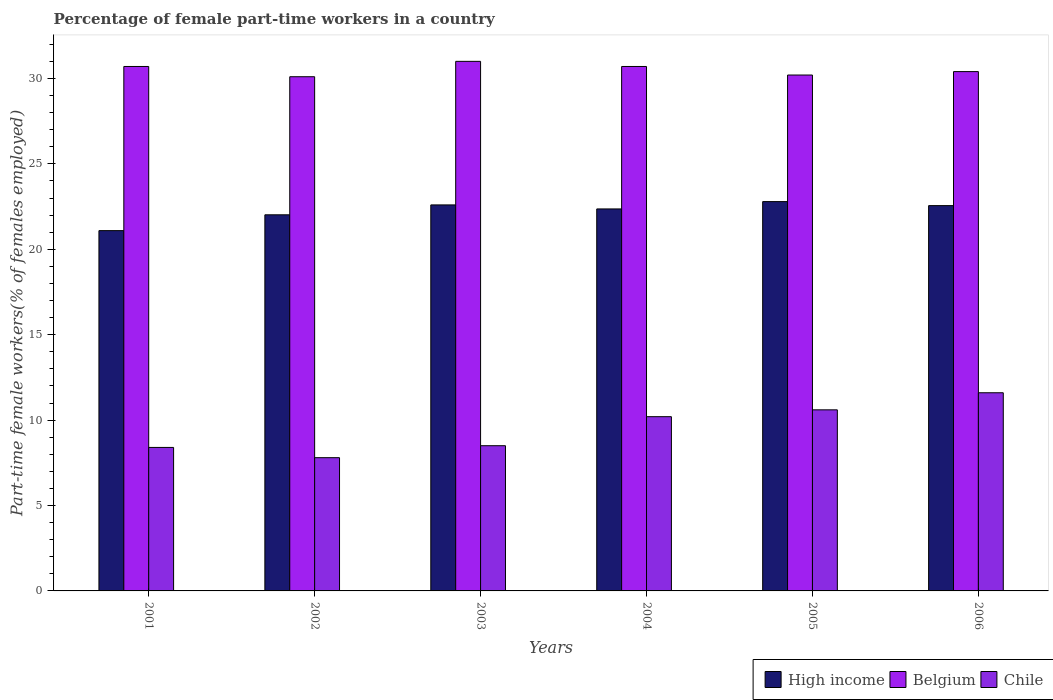How many groups of bars are there?
Keep it short and to the point. 6. Are the number of bars on each tick of the X-axis equal?
Ensure brevity in your answer.  Yes. What is the label of the 3rd group of bars from the left?
Provide a succinct answer. 2003. What is the percentage of female part-time workers in High income in 2001?
Your response must be concise. 21.09. Across all years, what is the minimum percentage of female part-time workers in High income?
Provide a short and direct response. 21.09. In which year was the percentage of female part-time workers in Chile minimum?
Provide a short and direct response. 2002. What is the total percentage of female part-time workers in Chile in the graph?
Your answer should be compact. 57.1. What is the difference between the percentage of female part-time workers in Belgium in 2003 and that in 2006?
Your answer should be compact. 0.6. What is the difference between the percentage of female part-time workers in High income in 2001 and the percentage of female part-time workers in Belgium in 2006?
Your response must be concise. -9.31. What is the average percentage of female part-time workers in High income per year?
Make the answer very short. 22.24. In the year 2001, what is the difference between the percentage of female part-time workers in Chile and percentage of female part-time workers in High income?
Provide a short and direct response. -12.69. In how many years, is the percentage of female part-time workers in Chile greater than 14 %?
Provide a succinct answer. 0. What is the ratio of the percentage of female part-time workers in Belgium in 2002 to that in 2006?
Keep it short and to the point. 0.99. What is the difference between the highest and the lowest percentage of female part-time workers in High income?
Ensure brevity in your answer.  1.7. In how many years, is the percentage of female part-time workers in Belgium greater than the average percentage of female part-time workers in Belgium taken over all years?
Provide a succinct answer. 3. Is the sum of the percentage of female part-time workers in Belgium in 2001 and 2003 greater than the maximum percentage of female part-time workers in Chile across all years?
Provide a succinct answer. Yes. What does the 1st bar from the left in 2005 represents?
Your response must be concise. High income. Is it the case that in every year, the sum of the percentage of female part-time workers in Belgium and percentage of female part-time workers in High income is greater than the percentage of female part-time workers in Chile?
Your answer should be compact. Yes. How many years are there in the graph?
Provide a short and direct response. 6. Are the values on the major ticks of Y-axis written in scientific E-notation?
Your answer should be very brief. No. Does the graph contain any zero values?
Provide a short and direct response. No. What is the title of the graph?
Your response must be concise. Percentage of female part-time workers in a country. Does "Slovak Republic" appear as one of the legend labels in the graph?
Offer a very short reply. No. What is the label or title of the X-axis?
Your response must be concise. Years. What is the label or title of the Y-axis?
Offer a terse response. Part-time female workers(% of females employed). What is the Part-time female workers(% of females employed) in High income in 2001?
Ensure brevity in your answer.  21.09. What is the Part-time female workers(% of females employed) in Belgium in 2001?
Provide a succinct answer. 30.7. What is the Part-time female workers(% of females employed) in Chile in 2001?
Ensure brevity in your answer.  8.4. What is the Part-time female workers(% of females employed) of High income in 2002?
Offer a very short reply. 22.02. What is the Part-time female workers(% of females employed) of Belgium in 2002?
Offer a very short reply. 30.1. What is the Part-time female workers(% of females employed) of Chile in 2002?
Your answer should be compact. 7.8. What is the Part-time female workers(% of females employed) in High income in 2003?
Your answer should be compact. 22.6. What is the Part-time female workers(% of females employed) in Belgium in 2003?
Provide a short and direct response. 31. What is the Part-time female workers(% of females employed) of Chile in 2003?
Offer a terse response. 8.5. What is the Part-time female workers(% of females employed) of High income in 2004?
Make the answer very short. 22.36. What is the Part-time female workers(% of females employed) of Belgium in 2004?
Make the answer very short. 30.7. What is the Part-time female workers(% of females employed) of Chile in 2004?
Your response must be concise. 10.2. What is the Part-time female workers(% of females employed) in High income in 2005?
Your response must be concise. 22.79. What is the Part-time female workers(% of females employed) of Belgium in 2005?
Your answer should be very brief. 30.2. What is the Part-time female workers(% of females employed) in Chile in 2005?
Offer a terse response. 10.6. What is the Part-time female workers(% of females employed) in High income in 2006?
Your response must be concise. 22.55. What is the Part-time female workers(% of females employed) of Belgium in 2006?
Make the answer very short. 30.4. What is the Part-time female workers(% of females employed) in Chile in 2006?
Your answer should be very brief. 11.6. Across all years, what is the maximum Part-time female workers(% of females employed) in High income?
Provide a succinct answer. 22.79. Across all years, what is the maximum Part-time female workers(% of females employed) of Belgium?
Offer a terse response. 31. Across all years, what is the maximum Part-time female workers(% of females employed) of Chile?
Offer a terse response. 11.6. Across all years, what is the minimum Part-time female workers(% of females employed) in High income?
Keep it short and to the point. 21.09. Across all years, what is the minimum Part-time female workers(% of females employed) of Belgium?
Give a very brief answer. 30.1. Across all years, what is the minimum Part-time female workers(% of females employed) of Chile?
Your answer should be very brief. 7.8. What is the total Part-time female workers(% of females employed) in High income in the graph?
Provide a succinct answer. 133.41. What is the total Part-time female workers(% of females employed) of Belgium in the graph?
Provide a short and direct response. 183.1. What is the total Part-time female workers(% of females employed) in Chile in the graph?
Your response must be concise. 57.1. What is the difference between the Part-time female workers(% of females employed) of High income in 2001 and that in 2002?
Ensure brevity in your answer.  -0.93. What is the difference between the Part-time female workers(% of females employed) in Chile in 2001 and that in 2002?
Make the answer very short. 0.6. What is the difference between the Part-time female workers(% of females employed) of High income in 2001 and that in 2003?
Offer a terse response. -1.51. What is the difference between the Part-time female workers(% of females employed) in Belgium in 2001 and that in 2003?
Offer a very short reply. -0.3. What is the difference between the Part-time female workers(% of females employed) of High income in 2001 and that in 2004?
Offer a terse response. -1.27. What is the difference between the Part-time female workers(% of females employed) in Belgium in 2001 and that in 2004?
Your response must be concise. 0. What is the difference between the Part-time female workers(% of females employed) of High income in 2001 and that in 2005?
Keep it short and to the point. -1.7. What is the difference between the Part-time female workers(% of females employed) of Chile in 2001 and that in 2005?
Keep it short and to the point. -2.2. What is the difference between the Part-time female workers(% of females employed) in High income in 2001 and that in 2006?
Your answer should be compact. -1.46. What is the difference between the Part-time female workers(% of females employed) in High income in 2002 and that in 2003?
Your answer should be compact. -0.58. What is the difference between the Part-time female workers(% of females employed) in Chile in 2002 and that in 2003?
Give a very brief answer. -0.7. What is the difference between the Part-time female workers(% of females employed) in High income in 2002 and that in 2004?
Your response must be concise. -0.34. What is the difference between the Part-time female workers(% of females employed) of High income in 2002 and that in 2005?
Offer a very short reply. -0.77. What is the difference between the Part-time female workers(% of females employed) in High income in 2002 and that in 2006?
Give a very brief answer. -0.54. What is the difference between the Part-time female workers(% of females employed) in Belgium in 2002 and that in 2006?
Keep it short and to the point. -0.3. What is the difference between the Part-time female workers(% of females employed) in Chile in 2002 and that in 2006?
Provide a succinct answer. -3.8. What is the difference between the Part-time female workers(% of females employed) of High income in 2003 and that in 2004?
Make the answer very short. 0.24. What is the difference between the Part-time female workers(% of females employed) of Chile in 2003 and that in 2004?
Your response must be concise. -1.7. What is the difference between the Part-time female workers(% of females employed) in High income in 2003 and that in 2005?
Keep it short and to the point. -0.19. What is the difference between the Part-time female workers(% of females employed) in Chile in 2003 and that in 2005?
Keep it short and to the point. -2.1. What is the difference between the Part-time female workers(% of females employed) in High income in 2003 and that in 2006?
Ensure brevity in your answer.  0.04. What is the difference between the Part-time female workers(% of females employed) of Chile in 2003 and that in 2006?
Provide a short and direct response. -3.1. What is the difference between the Part-time female workers(% of females employed) of High income in 2004 and that in 2005?
Provide a short and direct response. -0.43. What is the difference between the Part-time female workers(% of females employed) in High income in 2004 and that in 2006?
Offer a terse response. -0.19. What is the difference between the Part-time female workers(% of females employed) in Belgium in 2004 and that in 2006?
Keep it short and to the point. 0.3. What is the difference between the Part-time female workers(% of females employed) of Chile in 2004 and that in 2006?
Your answer should be compact. -1.4. What is the difference between the Part-time female workers(% of females employed) of High income in 2005 and that in 2006?
Your response must be concise. 0.24. What is the difference between the Part-time female workers(% of females employed) of Belgium in 2005 and that in 2006?
Offer a very short reply. -0.2. What is the difference between the Part-time female workers(% of females employed) of Chile in 2005 and that in 2006?
Provide a succinct answer. -1. What is the difference between the Part-time female workers(% of females employed) of High income in 2001 and the Part-time female workers(% of females employed) of Belgium in 2002?
Your answer should be compact. -9.01. What is the difference between the Part-time female workers(% of females employed) of High income in 2001 and the Part-time female workers(% of females employed) of Chile in 2002?
Make the answer very short. 13.29. What is the difference between the Part-time female workers(% of females employed) in Belgium in 2001 and the Part-time female workers(% of females employed) in Chile in 2002?
Offer a terse response. 22.9. What is the difference between the Part-time female workers(% of females employed) of High income in 2001 and the Part-time female workers(% of females employed) of Belgium in 2003?
Keep it short and to the point. -9.91. What is the difference between the Part-time female workers(% of females employed) of High income in 2001 and the Part-time female workers(% of females employed) of Chile in 2003?
Offer a terse response. 12.59. What is the difference between the Part-time female workers(% of females employed) in Belgium in 2001 and the Part-time female workers(% of females employed) in Chile in 2003?
Give a very brief answer. 22.2. What is the difference between the Part-time female workers(% of females employed) in High income in 2001 and the Part-time female workers(% of females employed) in Belgium in 2004?
Ensure brevity in your answer.  -9.61. What is the difference between the Part-time female workers(% of females employed) in High income in 2001 and the Part-time female workers(% of females employed) in Chile in 2004?
Give a very brief answer. 10.89. What is the difference between the Part-time female workers(% of females employed) in Belgium in 2001 and the Part-time female workers(% of females employed) in Chile in 2004?
Offer a very short reply. 20.5. What is the difference between the Part-time female workers(% of females employed) in High income in 2001 and the Part-time female workers(% of females employed) in Belgium in 2005?
Provide a succinct answer. -9.11. What is the difference between the Part-time female workers(% of females employed) in High income in 2001 and the Part-time female workers(% of females employed) in Chile in 2005?
Your response must be concise. 10.49. What is the difference between the Part-time female workers(% of females employed) of Belgium in 2001 and the Part-time female workers(% of females employed) of Chile in 2005?
Keep it short and to the point. 20.1. What is the difference between the Part-time female workers(% of females employed) of High income in 2001 and the Part-time female workers(% of females employed) of Belgium in 2006?
Offer a very short reply. -9.31. What is the difference between the Part-time female workers(% of females employed) of High income in 2001 and the Part-time female workers(% of females employed) of Chile in 2006?
Ensure brevity in your answer.  9.49. What is the difference between the Part-time female workers(% of females employed) in Belgium in 2001 and the Part-time female workers(% of females employed) in Chile in 2006?
Offer a very short reply. 19.1. What is the difference between the Part-time female workers(% of females employed) of High income in 2002 and the Part-time female workers(% of females employed) of Belgium in 2003?
Keep it short and to the point. -8.98. What is the difference between the Part-time female workers(% of females employed) in High income in 2002 and the Part-time female workers(% of females employed) in Chile in 2003?
Keep it short and to the point. 13.52. What is the difference between the Part-time female workers(% of females employed) in Belgium in 2002 and the Part-time female workers(% of females employed) in Chile in 2003?
Ensure brevity in your answer.  21.6. What is the difference between the Part-time female workers(% of females employed) in High income in 2002 and the Part-time female workers(% of females employed) in Belgium in 2004?
Provide a short and direct response. -8.68. What is the difference between the Part-time female workers(% of females employed) of High income in 2002 and the Part-time female workers(% of females employed) of Chile in 2004?
Your answer should be very brief. 11.82. What is the difference between the Part-time female workers(% of females employed) in Belgium in 2002 and the Part-time female workers(% of females employed) in Chile in 2004?
Your answer should be compact. 19.9. What is the difference between the Part-time female workers(% of females employed) in High income in 2002 and the Part-time female workers(% of females employed) in Belgium in 2005?
Your answer should be compact. -8.18. What is the difference between the Part-time female workers(% of females employed) in High income in 2002 and the Part-time female workers(% of females employed) in Chile in 2005?
Ensure brevity in your answer.  11.42. What is the difference between the Part-time female workers(% of females employed) in Belgium in 2002 and the Part-time female workers(% of females employed) in Chile in 2005?
Give a very brief answer. 19.5. What is the difference between the Part-time female workers(% of females employed) in High income in 2002 and the Part-time female workers(% of females employed) in Belgium in 2006?
Offer a very short reply. -8.38. What is the difference between the Part-time female workers(% of females employed) in High income in 2002 and the Part-time female workers(% of females employed) in Chile in 2006?
Give a very brief answer. 10.42. What is the difference between the Part-time female workers(% of females employed) of Belgium in 2002 and the Part-time female workers(% of females employed) of Chile in 2006?
Your answer should be compact. 18.5. What is the difference between the Part-time female workers(% of females employed) of High income in 2003 and the Part-time female workers(% of females employed) of Belgium in 2004?
Ensure brevity in your answer.  -8.1. What is the difference between the Part-time female workers(% of females employed) in High income in 2003 and the Part-time female workers(% of females employed) in Chile in 2004?
Offer a very short reply. 12.4. What is the difference between the Part-time female workers(% of females employed) of Belgium in 2003 and the Part-time female workers(% of females employed) of Chile in 2004?
Provide a succinct answer. 20.8. What is the difference between the Part-time female workers(% of females employed) in High income in 2003 and the Part-time female workers(% of females employed) in Belgium in 2005?
Provide a succinct answer. -7.6. What is the difference between the Part-time female workers(% of females employed) of High income in 2003 and the Part-time female workers(% of females employed) of Chile in 2005?
Make the answer very short. 12. What is the difference between the Part-time female workers(% of females employed) of Belgium in 2003 and the Part-time female workers(% of females employed) of Chile in 2005?
Give a very brief answer. 20.4. What is the difference between the Part-time female workers(% of females employed) of High income in 2003 and the Part-time female workers(% of females employed) of Belgium in 2006?
Your answer should be very brief. -7.8. What is the difference between the Part-time female workers(% of females employed) of High income in 2003 and the Part-time female workers(% of females employed) of Chile in 2006?
Offer a very short reply. 11. What is the difference between the Part-time female workers(% of females employed) of High income in 2004 and the Part-time female workers(% of females employed) of Belgium in 2005?
Give a very brief answer. -7.84. What is the difference between the Part-time female workers(% of females employed) of High income in 2004 and the Part-time female workers(% of females employed) of Chile in 2005?
Provide a short and direct response. 11.76. What is the difference between the Part-time female workers(% of females employed) of Belgium in 2004 and the Part-time female workers(% of females employed) of Chile in 2005?
Give a very brief answer. 20.1. What is the difference between the Part-time female workers(% of females employed) of High income in 2004 and the Part-time female workers(% of females employed) of Belgium in 2006?
Give a very brief answer. -8.04. What is the difference between the Part-time female workers(% of females employed) in High income in 2004 and the Part-time female workers(% of females employed) in Chile in 2006?
Offer a very short reply. 10.76. What is the difference between the Part-time female workers(% of females employed) of High income in 2005 and the Part-time female workers(% of females employed) of Belgium in 2006?
Give a very brief answer. -7.61. What is the difference between the Part-time female workers(% of females employed) in High income in 2005 and the Part-time female workers(% of females employed) in Chile in 2006?
Your answer should be very brief. 11.19. What is the average Part-time female workers(% of females employed) of High income per year?
Your answer should be very brief. 22.24. What is the average Part-time female workers(% of females employed) in Belgium per year?
Your answer should be compact. 30.52. What is the average Part-time female workers(% of females employed) in Chile per year?
Offer a terse response. 9.52. In the year 2001, what is the difference between the Part-time female workers(% of females employed) of High income and Part-time female workers(% of females employed) of Belgium?
Provide a succinct answer. -9.61. In the year 2001, what is the difference between the Part-time female workers(% of females employed) in High income and Part-time female workers(% of females employed) in Chile?
Your answer should be very brief. 12.69. In the year 2001, what is the difference between the Part-time female workers(% of females employed) of Belgium and Part-time female workers(% of females employed) of Chile?
Provide a short and direct response. 22.3. In the year 2002, what is the difference between the Part-time female workers(% of females employed) of High income and Part-time female workers(% of females employed) of Belgium?
Your response must be concise. -8.08. In the year 2002, what is the difference between the Part-time female workers(% of females employed) of High income and Part-time female workers(% of females employed) of Chile?
Provide a succinct answer. 14.22. In the year 2002, what is the difference between the Part-time female workers(% of females employed) in Belgium and Part-time female workers(% of females employed) in Chile?
Ensure brevity in your answer.  22.3. In the year 2003, what is the difference between the Part-time female workers(% of females employed) of High income and Part-time female workers(% of females employed) of Belgium?
Your answer should be very brief. -8.4. In the year 2003, what is the difference between the Part-time female workers(% of females employed) of High income and Part-time female workers(% of females employed) of Chile?
Your answer should be very brief. 14.1. In the year 2003, what is the difference between the Part-time female workers(% of females employed) in Belgium and Part-time female workers(% of females employed) in Chile?
Make the answer very short. 22.5. In the year 2004, what is the difference between the Part-time female workers(% of females employed) in High income and Part-time female workers(% of females employed) in Belgium?
Provide a short and direct response. -8.34. In the year 2004, what is the difference between the Part-time female workers(% of females employed) in High income and Part-time female workers(% of females employed) in Chile?
Make the answer very short. 12.16. In the year 2004, what is the difference between the Part-time female workers(% of females employed) of Belgium and Part-time female workers(% of females employed) of Chile?
Offer a terse response. 20.5. In the year 2005, what is the difference between the Part-time female workers(% of females employed) of High income and Part-time female workers(% of females employed) of Belgium?
Keep it short and to the point. -7.41. In the year 2005, what is the difference between the Part-time female workers(% of females employed) of High income and Part-time female workers(% of females employed) of Chile?
Provide a short and direct response. 12.19. In the year 2005, what is the difference between the Part-time female workers(% of females employed) in Belgium and Part-time female workers(% of females employed) in Chile?
Ensure brevity in your answer.  19.6. In the year 2006, what is the difference between the Part-time female workers(% of females employed) of High income and Part-time female workers(% of females employed) of Belgium?
Ensure brevity in your answer.  -7.85. In the year 2006, what is the difference between the Part-time female workers(% of females employed) of High income and Part-time female workers(% of females employed) of Chile?
Make the answer very short. 10.95. What is the ratio of the Part-time female workers(% of females employed) in High income in 2001 to that in 2002?
Offer a very short reply. 0.96. What is the ratio of the Part-time female workers(% of females employed) in Belgium in 2001 to that in 2002?
Your answer should be very brief. 1.02. What is the ratio of the Part-time female workers(% of females employed) in High income in 2001 to that in 2003?
Give a very brief answer. 0.93. What is the ratio of the Part-time female workers(% of females employed) of Belgium in 2001 to that in 2003?
Keep it short and to the point. 0.99. What is the ratio of the Part-time female workers(% of females employed) of Chile in 2001 to that in 2003?
Give a very brief answer. 0.99. What is the ratio of the Part-time female workers(% of females employed) in High income in 2001 to that in 2004?
Offer a very short reply. 0.94. What is the ratio of the Part-time female workers(% of females employed) of Chile in 2001 to that in 2004?
Provide a short and direct response. 0.82. What is the ratio of the Part-time female workers(% of females employed) of High income in 2001 to that in 2005?
Your response must be concise. 0.93. What is the ratio of the Part-time female workers(% of females employed) in Belgium in 2001 to that in 2005?
Make the answer very short. 1.02. What is the ratio of the Part-time female workers(% of females employed) of Chile in 2001 to that in 2005?
Keep it short and to the point. 0.79. What is the ratio of the Part-time female workers(% of females employed) in High income in 2001 to that in 2006?
Provide a short and direct response. 0.94. What is the ratio of the Part-time female workers(% of females employed) of Belgium in 2001 to that in 2006?
Your response must be concise. 1.01. What is the ratio of the Part-time female workers(% of females employed) in Chile in 2001 to that in 2006?
Provide a short and direct response. 0.72. What is the ratio of the Part-time female workers(% of females employed) in High income in 2002 to that in 2003?
Ensure brevity in your answer.  0.97. What is the ratio of the Part-time female workers(% of females employed) of Chile in 2002 to that in 2003?
Ensure brevity in your answer.  0.92. What is the ratio of the Part-time female workers(% of females employed) in High income in 2002 to that in 2004?
Your answer should be compact. 0.98. What is the ratio of the Part-time female workers(% of females employed) in Belgium in 2002 to that in 2004?
Make the answer very short. 0.98. What is the ratio of the Part-time female workers(% of females employed) in Chile in 2002 to that in 2004?
Make the answer very short. 0.76. What is the ratio of the Part-time female workers(% of females employed) of High income in 2002 to that in 2005?
Your answer should be very brief. 0.97. What is the ratio of the Part-time female workers(% of females employed) in Chile in 2002 to that in 2005?
Provide a short and direct response. 0.74. What is the ratio of the Part-time female workers(% of females employed) in High income in 2002 to that in 2006?
Give a very brief answer. 0.98. What is the ratio of the Part-time female workers(% of females employed) in Chile in 2002 to that in 2006?
Provide a short and direct response. 0.67. What is the ratio of the Part-time female workers(% of females employed) in High income in 2003 to that in 2004?
Your response must be concise. 1.01. What is the ratio of the Part-time female workers(% of females employed) of Belgium in 2003 to that in 2004?
Provide a succinct answer. 1.01. What is the ratio of the Part-time female workers(% of females employed) in High income in 2003 to that in 2005?
Ensure brevity in your answer.  0.99. What is the ratio of the Part-time female workers(% of females employed) of Belgium in 2003 to that in 2005?
Offer a very short reply. 1.03. What is the ratio of the Part-time female workers(% of females employed) of Chile in 2003 to that in 2005?
Your answer should be very brief. 0.8. What is the ratio of the Part-time female workers(% of females employed) in Belgium in 2003 to that in 2006?
Give a very brief answer. 1.02. What is the ratio of the Part-time female workers(% of females employed) of Chile in 2003 to that in 2006?
Offer a terse response. 0.73. What is the ratio of the Part-time female workers(% of females employed) of High income in 2004 to that in 2005?
Your answer should be compact. 0.98. What is the ratio of the Part-time female workers(% of females employed) in Belgium in 2004 to that in 2005?
Provide a succinct answer. 1.02. What is the ratio of the Part-time female workers(% of females employed) in Chile in 2004 to that in 2005?
Keep it short and to the point. 0.96. What is the ratio of the Part-time female workers(% of females employed) of Belgium in 2004 to that in 2006?
Your answer should be compact. 1.01. What is the ratio of the Part-time female workers(% of females employed) of Chile in 2004 to that in 2006?
Provide a succinct answer. 0.88. What is the ratio of the Part-time female workers(% of females employed) of High income in 2005 to that in 2006?
Keep it short and to the point. 1.01. What is the ratio of the Part-time female workers(% of females employed) of Chile in 2005 to that in 2006?
Make the answer very short. 0.91. What is the difference between the highest and the second highest Part-time female workers(% of females employed) in High income?
Your answer should be very brief. 0.19. What is the difference between the highest and the second highest Part-time female workers(% of females employed) in Belgium?
Offer a very short reply. 0.3. What is the difference between the highest and the second highest Part-time female workers(% of females employed) of Chile?
Offer a very short reply. 1. What is the difference between the highest and the lowest Part-time female workers(% of females employed) in High income?
Give a very brief answer. 1.7. What is the difference between the highest and the lowest Part-time female workers(% of females employed) in Belgium?
Keep it short and to the point. 0.9. 